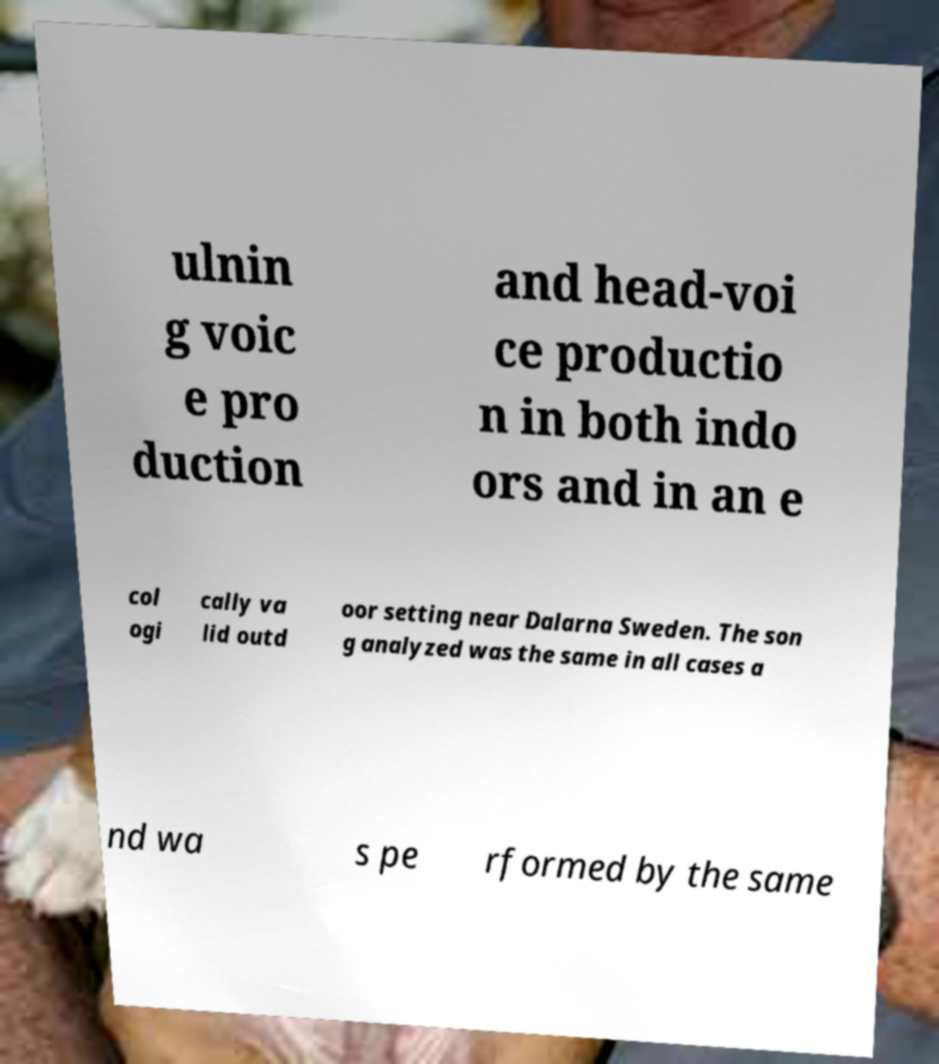I need the written content from this picture converted into text. Can you do that? ulnin g voic e pro duction and head-voi ce productio n in both indo ors and in an e col ogi cally va lid outd oor setting near Dalarna Sweden. The son g analyzed was the same in all cases a nd wa s pe rformed by the same 